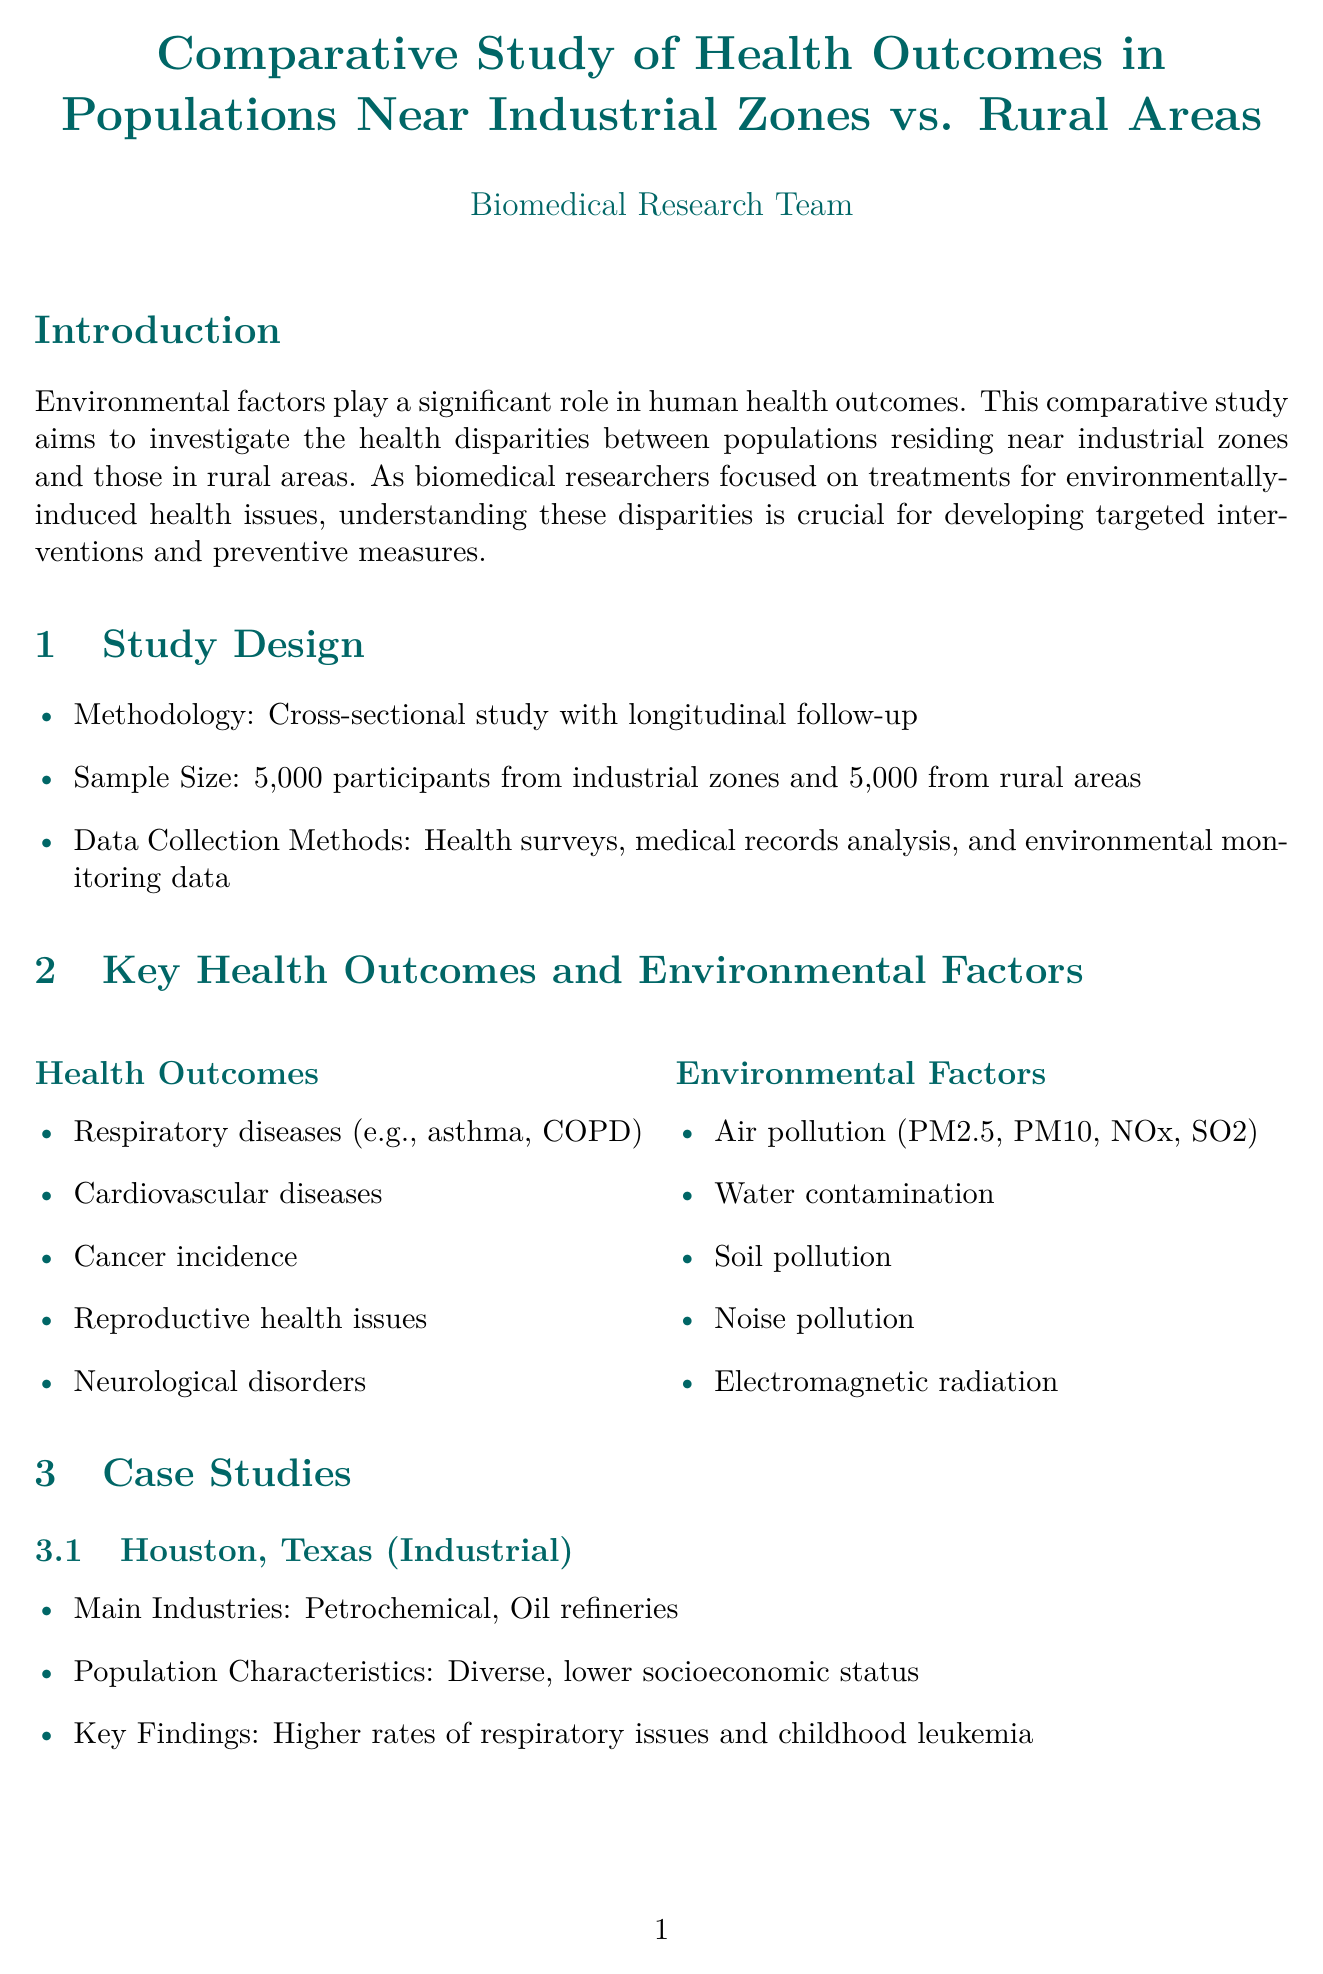What is the sample size for the industrial zone? The document states that the sample size for the industrial zone is 5,000 participants.
Answer: 5,000 What are the main industries in Houston, Texas? The document lists the main industries in Houston, Texas as Petrochemical and Oil refineries.
Answer: Petrochemical, Oil refineries What percentage of asthma prevalence was found in the industrial zone? The document presents that the asthma prevalence in the industrial zone is 12.3%.
Answer: 12.3% What is one potential mechanism for health issues identified in the discussion? The document mentions chronic exposure to air pollutants as one potential mechanism for health issues.
Answer: Chronic exposure to air pollutants What policy recommendation is made regarding urban planning? The document recommends improved urban planning to create buffer zones between residential areas and industrial sites.
Answer: Improved urban planning to create buffer zones What statistical analysis method was used in the study? The document states that multivariate regression analysis was one of the statistical analysis methods used.
Answer: Multivariate regression analysis 